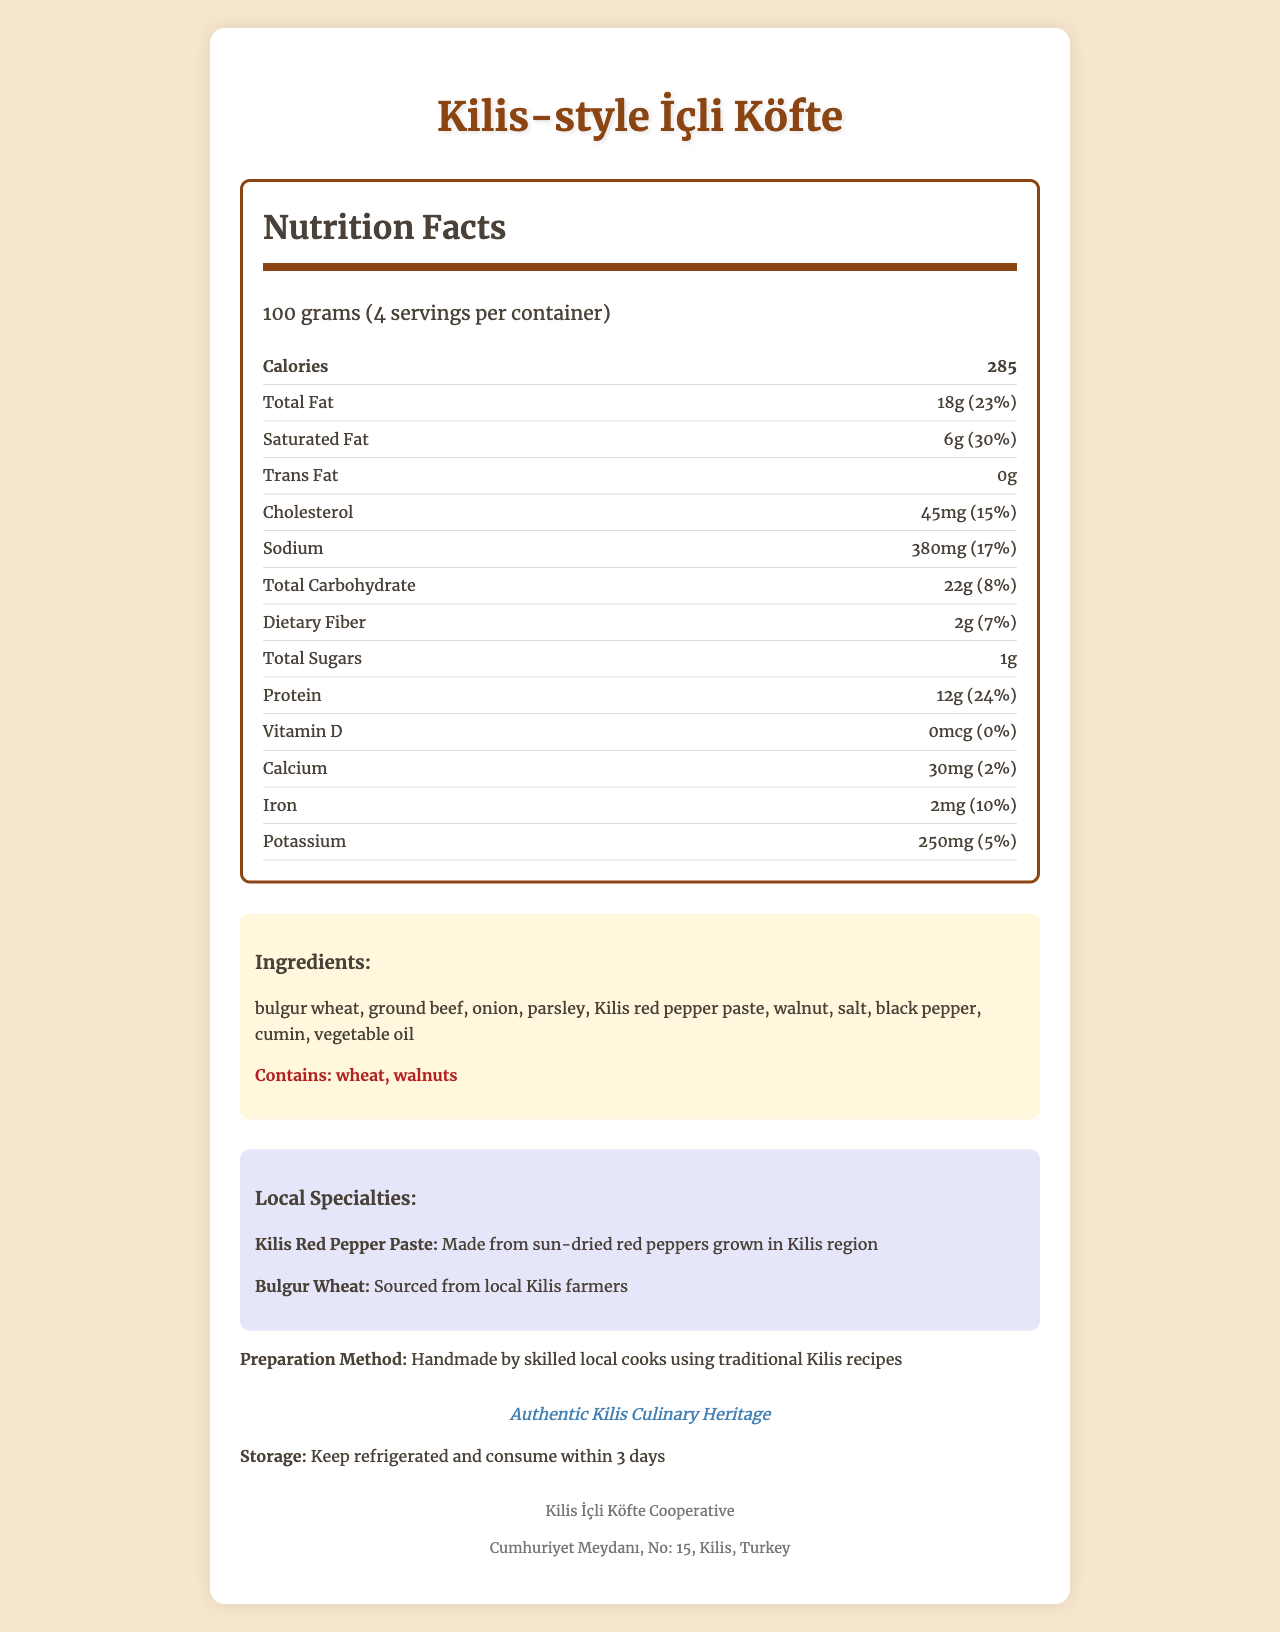what is the serving size of Kilis-style İçli Köfte? The document specifies that the serving size is 100 grams.
Answer: 100 grams how many calories are in one serving of Kilis-style İçli Köfte? The document shows that each 100 gram serving contains 285 calories.
Answer: 285 what is the total fat content per serving of Kilis-style İçli Köfte? The total fat content per serving is listed as 18 grams.
Answer: 18 grams what are the two main allergens in Kilis-style İçli Köfte? The allergens section indicates that the main allergens are wheat and walnuts.
Answer: Wheat and Walnuts what is the daily value percentage of protein content per serving? The document lists the protein content's daily value percentage as 24%.
Answer: 24% how much sodium is in one serving of Kilis-style İçli Köfte? A. 100 mg B. 250 mg C. 380 mg D. 500 mg The document indicates that one serving contains 380 mg of sodium.
Answer: C. 380 mg which of the following is not an ingredient of Kilis-style İçli Köfte? I. Bulgur wheat II. Parsley III. Cinnamon IV. Onion The ingredients listed are bulgur wheat, ground beef, onion, parsley, Kilis red pepper paste, walnut, salt, black pepper, cumin, and vegetable oil; cinnamon is not mentioned.
Answer: III. Cinnamon does Kilis-style İçli Köfte contain trans fat? The document states that the amount of trans fat is 0 grams.
Answer: No describe the unique selling points of Kilis-style İçli Köfte. The local specialties section highlights the unique ingredients and preparation methods, emphasizing the traditional recipes and authentic certification.
Answer: Kilis-style İçli Köfte is a local specialty made with sun-dried red peppers and bulgur wheat sourced from Kilis farmers. It is handmade using traditional Kilis recipes and is certified as authentic Kilis Culinary Heritage. what is the dietary fiber content in one serving of Kilis-style İçli Köfte? The document shows that the dietary fiber content per serving is 2 grams.
Answer: 2 grams who is the manufacturer of Kilis-style İçli Köfte? The footer indicates that the manufacturer is Kilis İçli Köfte Cooperative.
Answer: Kilis İçli Köfte Cooperative how should Kilis-style İçli Köfte be stored? The storage instructions advise keeping the product refrigerated and consuming it within 3 days.
Answer: Keep refrigerated and consume within 3 days what is the main ingredient contributing to the carbohydrate content in Kilis-style İçli Köfte? The main ingredient for carbohydrates is bulgur wheat, as it's a key component in the recipe.
Answer: Bulgur wheat what percentage of the daily value of calcium does one serving of Kilis-style İçli Köfte provide? The daily value percentage of calcium is listed as 2%.
Answer: 2% where is the manufacturer located? The manufacturer's address is specified as Cumhuriyet Meydanı, No: 15, Kilis, Turkey.
Answer: Cumhuriyet Meydanı, No: 15, Kilis, Turkey what motivated the recipe for Kilis-style İçli Köfte? The document does not provide information about the motivation behind the recipe.
Answer: Not enough information 